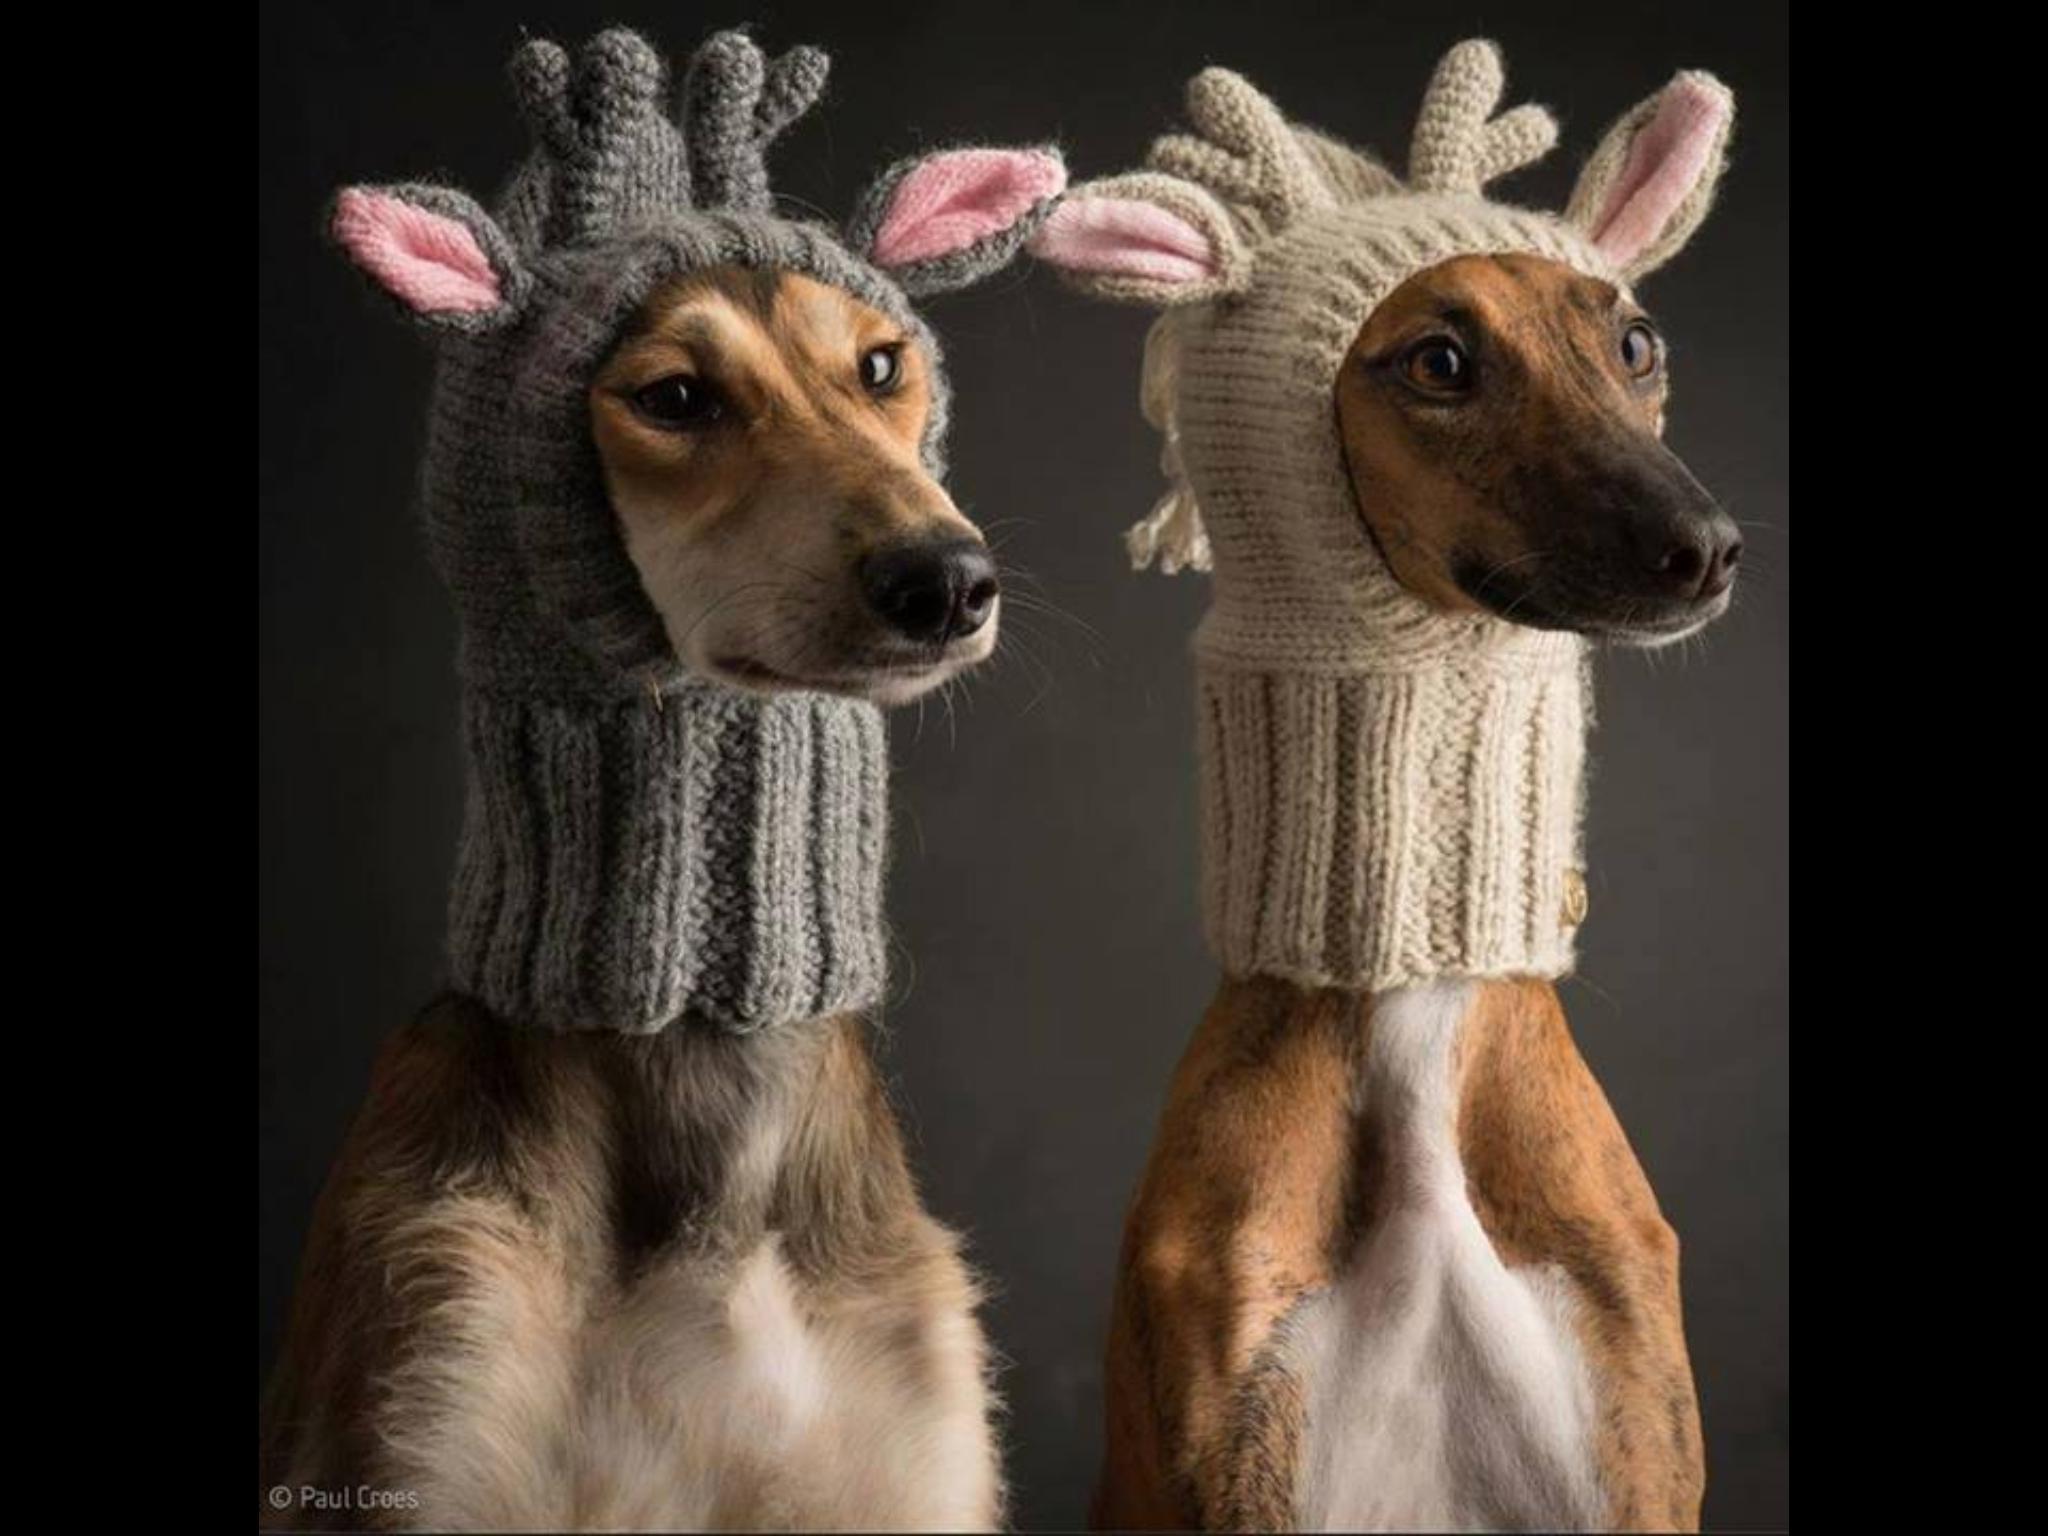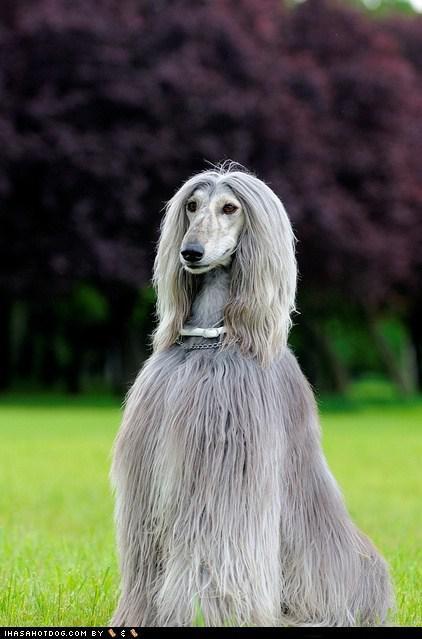The first image is the image on the left, the second image is the image on the right. Given the left and right images, does the statement "An image includes a dog wearing something that covers its neck and the top of its head." hold true? Answer yes or no. Yes. The first image is the image on the left, the second image is the image on the right. For the images shown, is this caption "In one image, one or more dogs with a long snout and black nose is wearing a head covering that extends down the neck, while a single dog in the second image is bareheaded." true? Answer yes or no. Yes. 